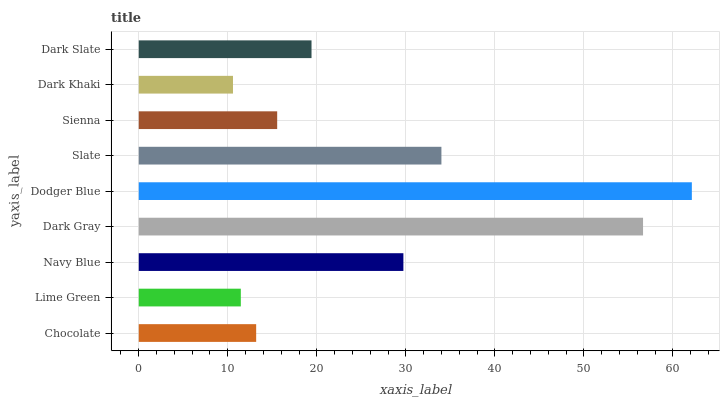Is Dark Khaki the minimum?
Answer yes or no. Yes. Is Dodger Blue the maximum?
Answer yes or no. Yes. Is Lime Green the minimum?
Answer yes or no. No. Is Lime Green the maximum?
Answer yes or no. No. Is Chocolate greater than Lime Green?
Answer yes or no. Yes. Is Lime Green less than Chocolate?
Answer yes or no. Yes. Is Lime Green greater than Chocolate?
Answer yes or no. No. Is Chocolate less than Lime Green?
Answer yes or no. No. Is Dark Slate the high median?
Answer yes or no. Yes. Is Dark Slate the low median?
Answer yes or no. Yes. Is Chocolate the high median?
Answer yes or no. No. Is Slate the low median?
Answer yes or no. No. 